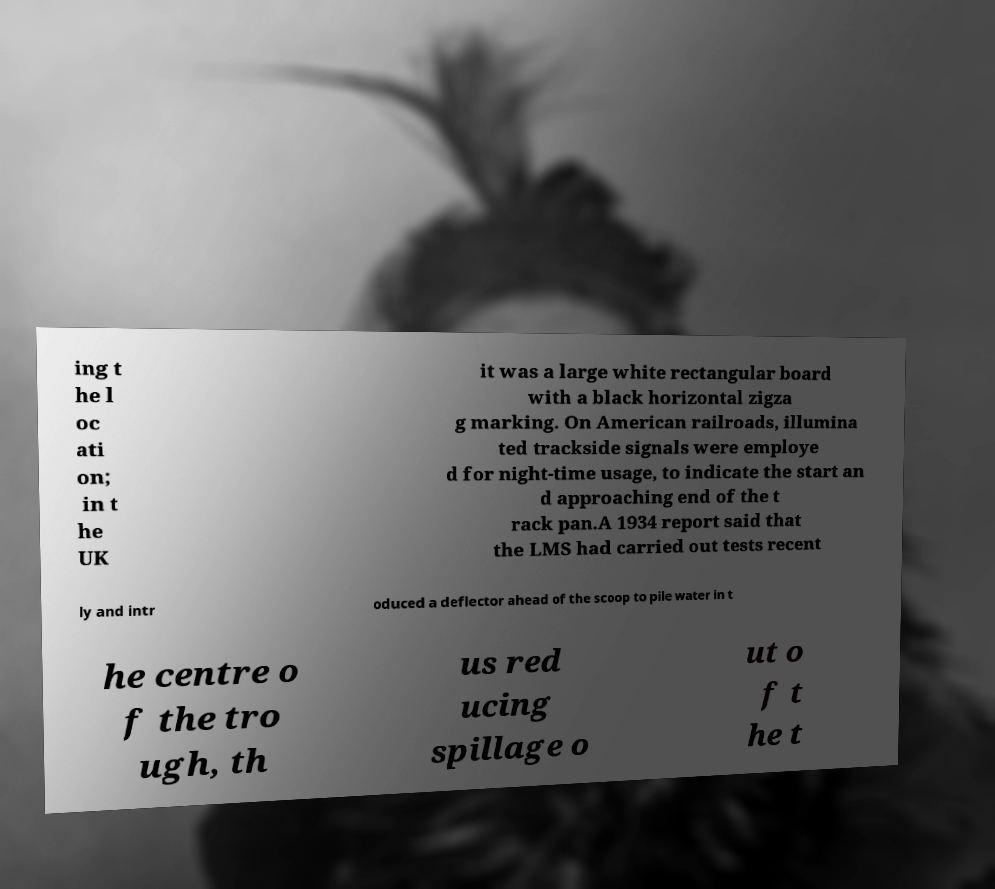Could you assist in decoding the text presented in this image and type it out clearly? ing t he l oc ati on; in t he UK it was a large white rectangular board with a black horizontal zigza g marking. On American railroads, illumina ted trackside signals were employe d for night-time usage, to indicate the start an d approaching end of the t rack pan.A 1934 report said that the LMS had carried out tests recent ly and intr oduced a deflector ahead of the scoop to pile water in t he centre o f the tro ugh, th us red ucing spillage o ut o f t he t 